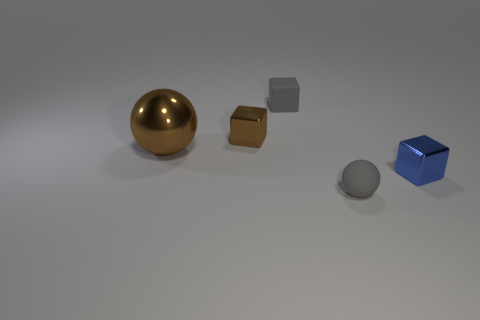What number of small gray balls are there?
Keep it short and to the point. 1. Does the small brown block have the same material as the large sphere?
Ensure brevity in your answer.  Yes. The tiny gray rubber object that is behind the tiny shiny cube to the right of the shiny cube that is behind the blue metallic cube is what shape?
Ensure brevity in your answer.  Cube. Is the material of the tiny gray thing in front of the small gray cube the same as the block that is to the right of the small rubber ball?
Keep it short and to the point. No. What is the material of the gray cube?
Keep it short and to the point. Rubber. What number of other big metal objects have the same shape as the big object?
Make the answer very short. 0. What is the material of the object that is the same color as the small matte ball?
Your answer should be compact. Rubber. What color is the tiny metallic block on the right side of the gray object to the left of the rubber object in front of the brown shiny block?
Provide a short and direct response. Blue. What number of tiny objects are blocks or gray things?
Make the answer very short. 4. Is the number of tiny blue things to the left of the small blue object the same as the number of purple rubber spheres?
Ensure brevity in your answer.  Yes. 